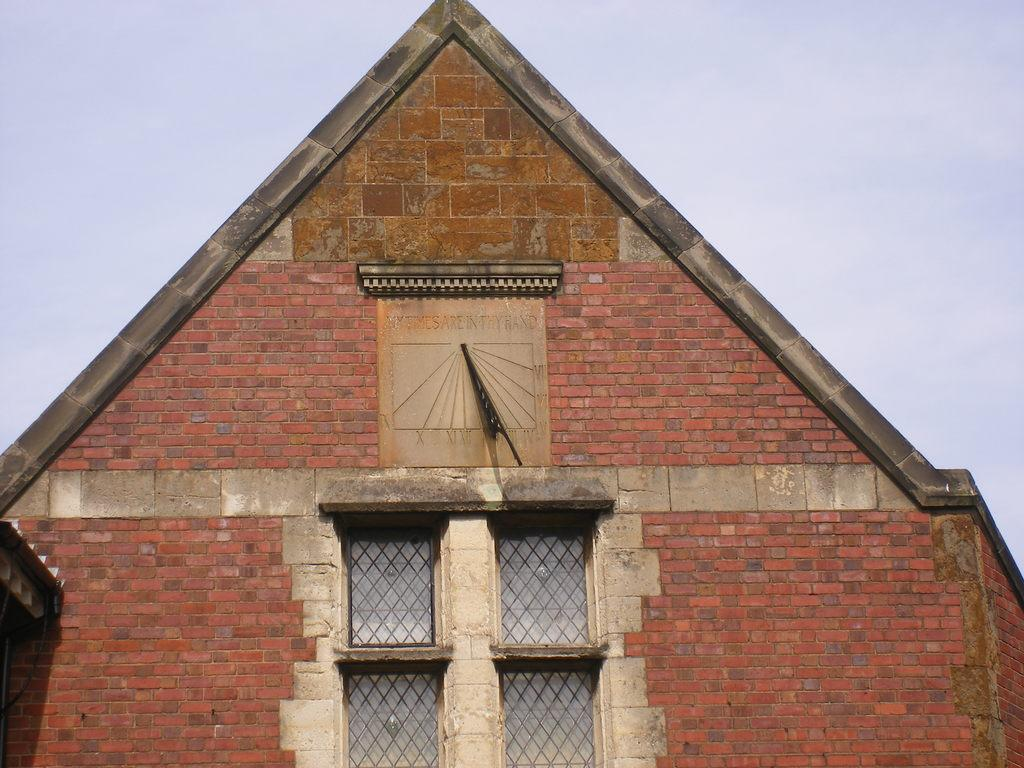What type of structure is present in the image? There is a building in the image. What feature can be seen on the building? The building has a clock. What else can be observed about the building's design? The building has windows. What can be seen in the background of the image? The sky is visible in the background of the image. Where is the nest located in the image? There is no nest present in the image. What type of nail is being used to hang the clock on the building? There is no nail mentioned or visible in the image; the clock is simply a feature of the building. 